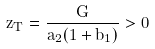<formula> <loc_0><loc_0><loc_500><loc_500>z _ { T } = \frac { G } { a _ { 2 } ( 1 + b _ { 1 } ) } > 0</formula> 